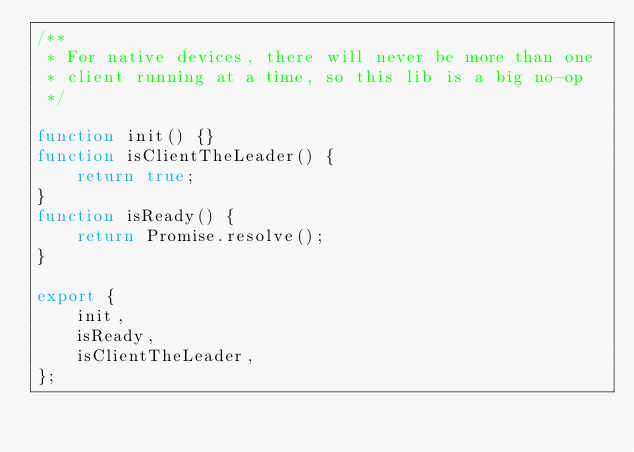<code> <loc_0><loc_0><loc_500><loc_500><_JavaScript_>/**
 * For native devices, there will never be more than one
 * client running at a time, so this lib is a big no-op
 */

function init() {}
function isClientTheLeader() {
    return true;
}
function isReady() {
    return Promise.resolve();
}

export {
    init,
    isReady,
    isClientTheLeader,
};
</code> 